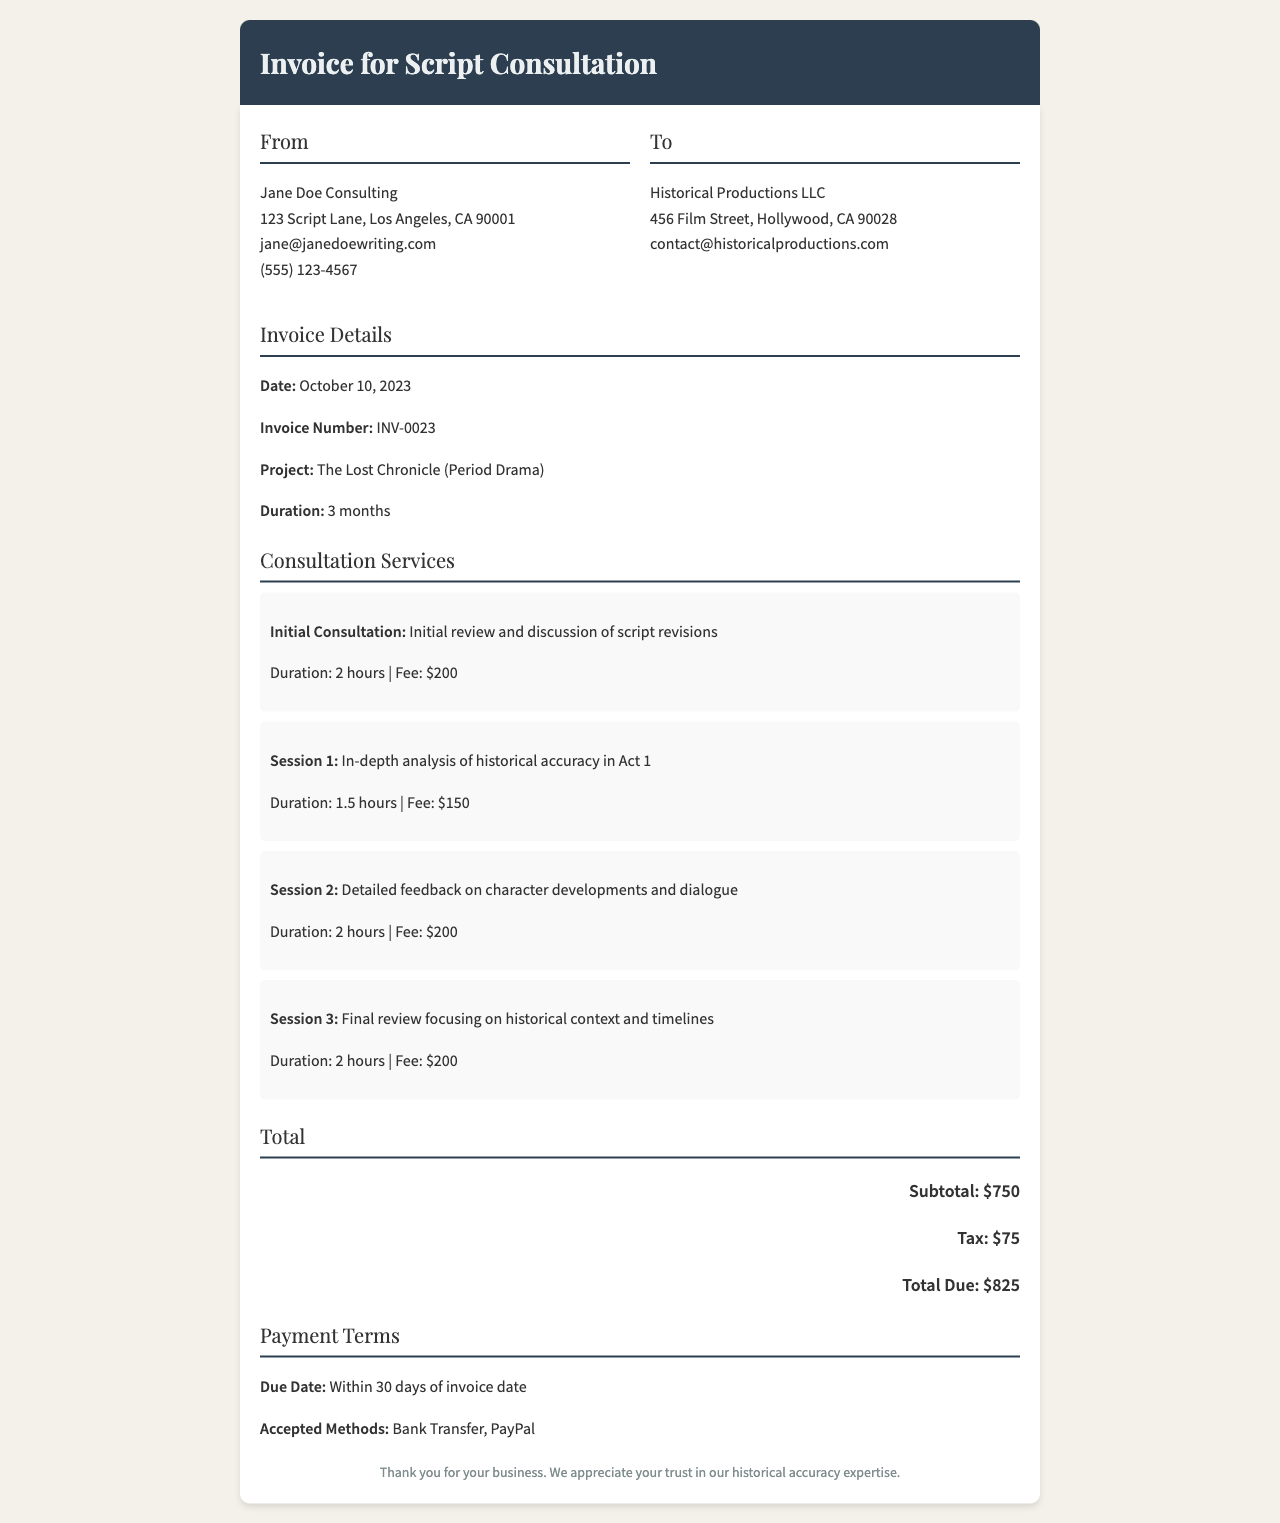what is the total due amount? The total due amount is provided in the invoice's total section, which sums the subtotal and tax.
Answer: $825 who is the consultant? The consultant's name appears at the top of the invoice under the "From" section.
Answer: Jane Doe Consulting what is the invoice number? The invoice number is listed in the "Invoice Details" section of the document.
Answer: INV-0023 how long did the consultations last in total? The total duration of consultations can be calculated by adding up each session's duration listed in the services section.
Answer: 7.5 hours what is the due date for payment? The due date for payment is specified in the "Payment Terms" section.
Answer: Within 30 days of invoice date what is the fee for the Initial Consultation? The fee for the Initial Consultation is mentioned in the consultation services breakdown.
Answer: $200 how many consultation sessions were held? The number of consultation sessions can be counted from the "Consultation Services" section.
Answer: 4 what is the tax amount included in the invoice? The tax amount is explicitly shown in the total section of the invoice.
Answer: $75 what are the accepted payment methods? The accepted methods for payment are listed in the "Payment Terms" section.
Answer: Bank Transfer, PayPal 